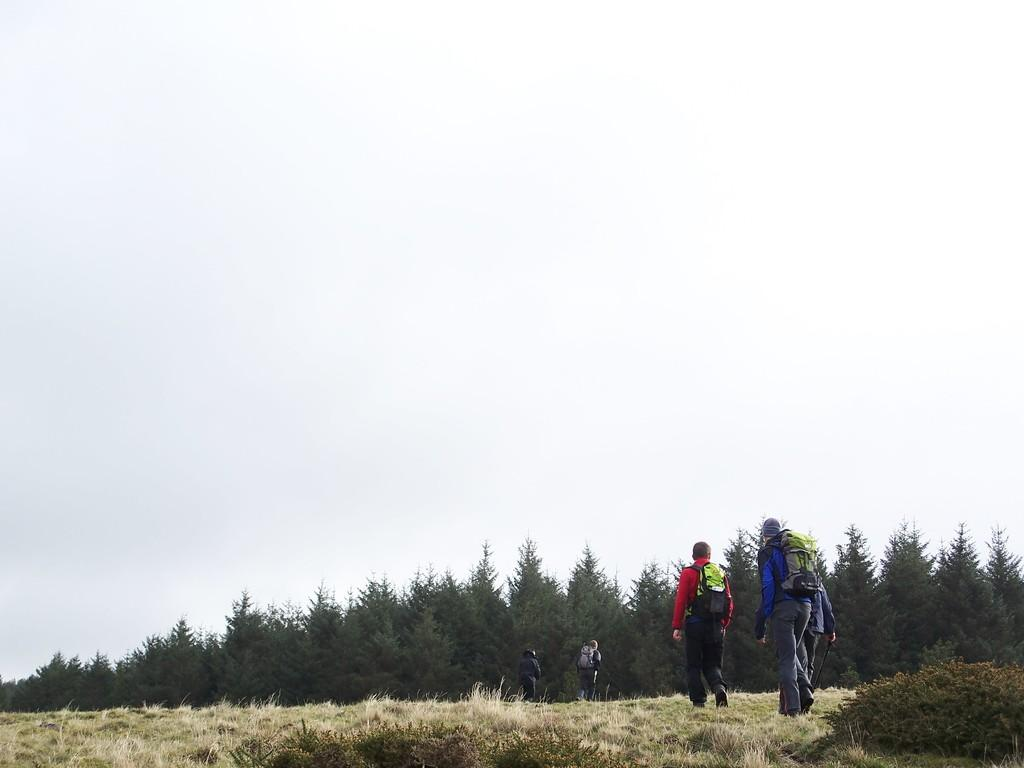What type of vegetation is present in the image? There is grass in the image. What are the people in the image doing? The people in the image are on the ground and carrying bags. What can be seen in the background of the image? There are trees and the sky visible in the background of the image. Can you tell me how many experts are present in the image? There is no mention of experts in the image, so it is not possible to determine their presence or number. 